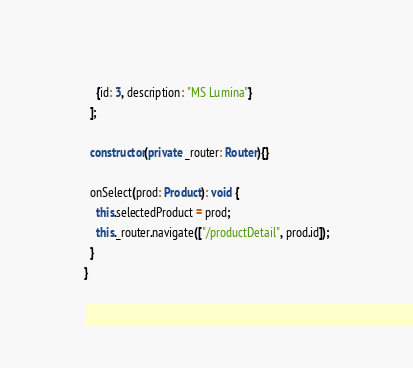<code> <loc_0><loc_0><loc_500><loc_500><_TypeScript_>    {id: 3, description: "MS Lumina"}
  ];

  constructor(private _router: Router){}

  onSelect(prod: Product): void {
    this.selectedProduct = prod;
    this._router.navigate(["/productDetail", prod.id]);
  }
}
</code> 